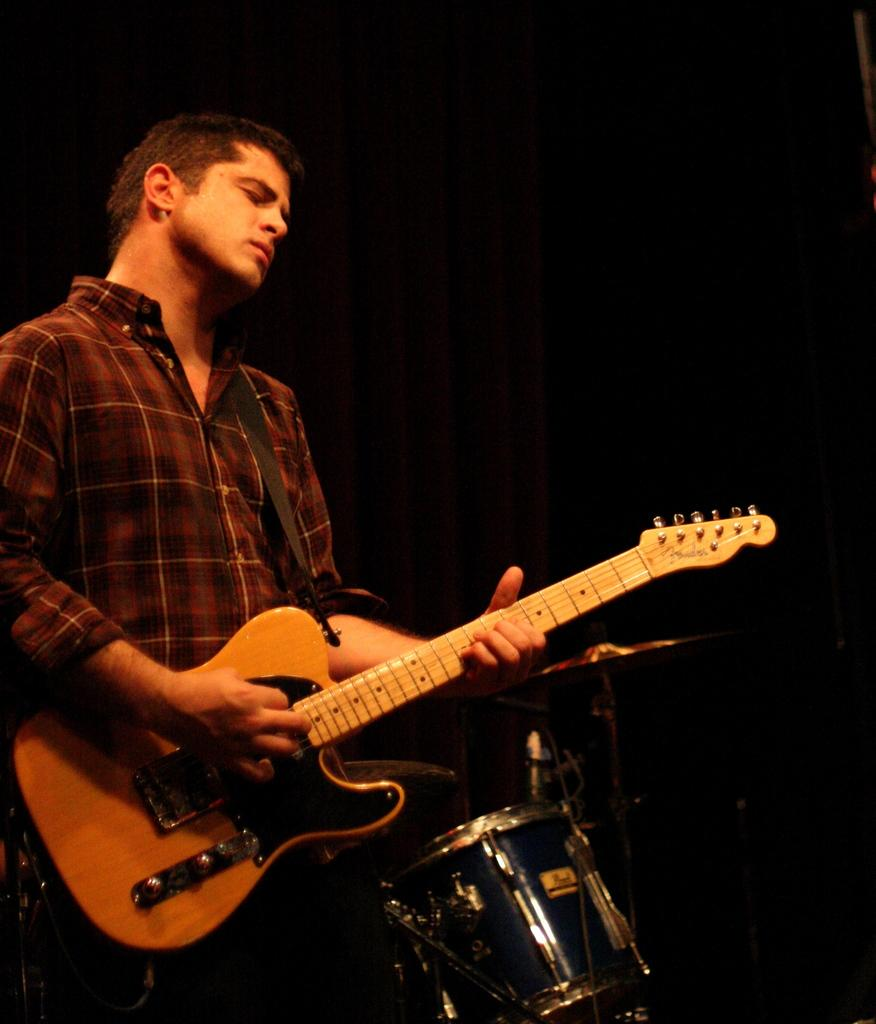What is the man in the image holding? The man is holding a guitar. What is the man doing with the guitar? The man is playing the guitar. What other musical instrument is visible in the image? There are drums beside the man. What can be seen in the background of the image? There is a dark curtain and a man wearing a shirt in the background of the image. What type of fish can be seen swimming in the background of the image? There are no fish present in the image; it features a man playing a guitar with drums beside him and a dark curtain in the background. 